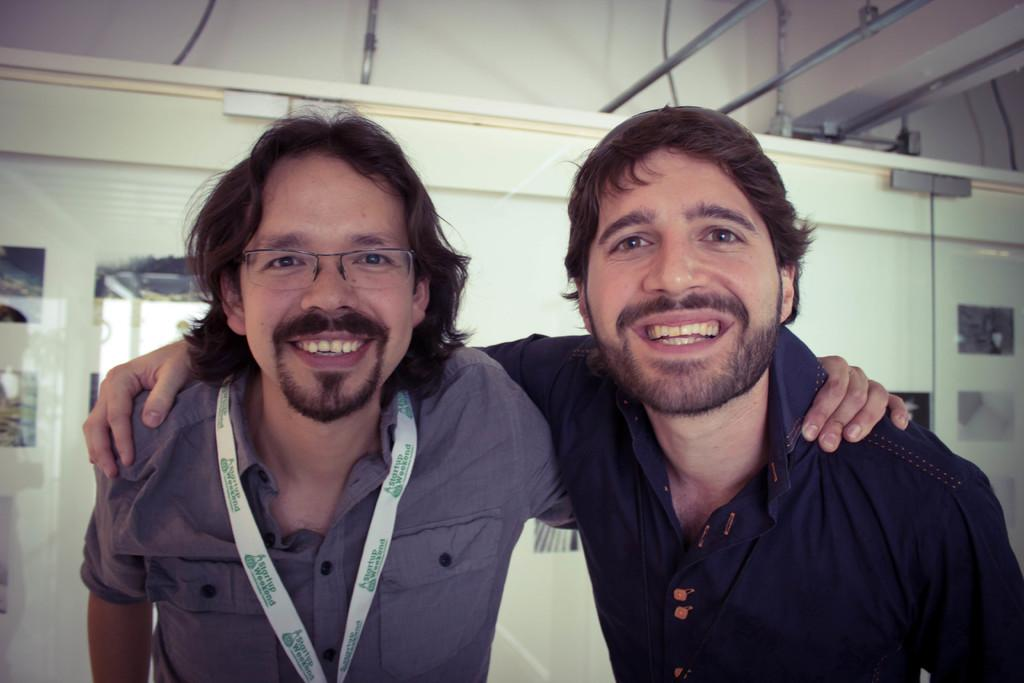How many people are in the image? There are two persons in the image. What are the persons doing in the image? The persons are standing and smiling. What can be seen in the background of the image? There is a wall in the background of the image. What type of rice is being served in the image? There is no rice present in the image; it features two persons standing and smiling. Where is the nest located in the image? There is no nest present in the image. 